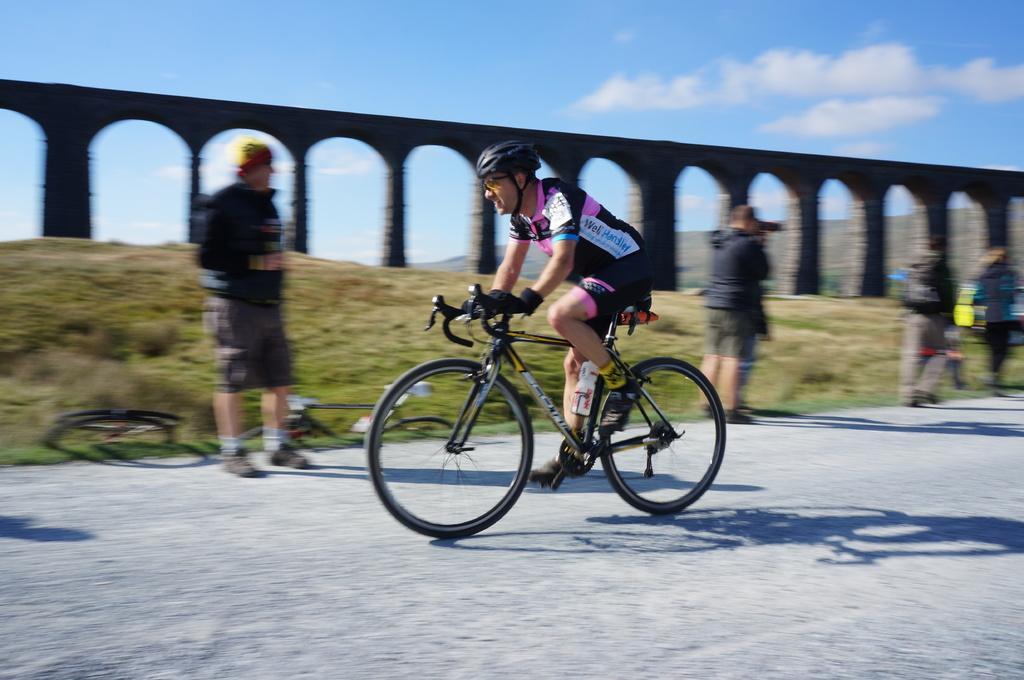Please provide a concise description of this image. In this image I can see a person riding bicycle. At the back of him there are many people standing and I can also see sky and the clouds. 